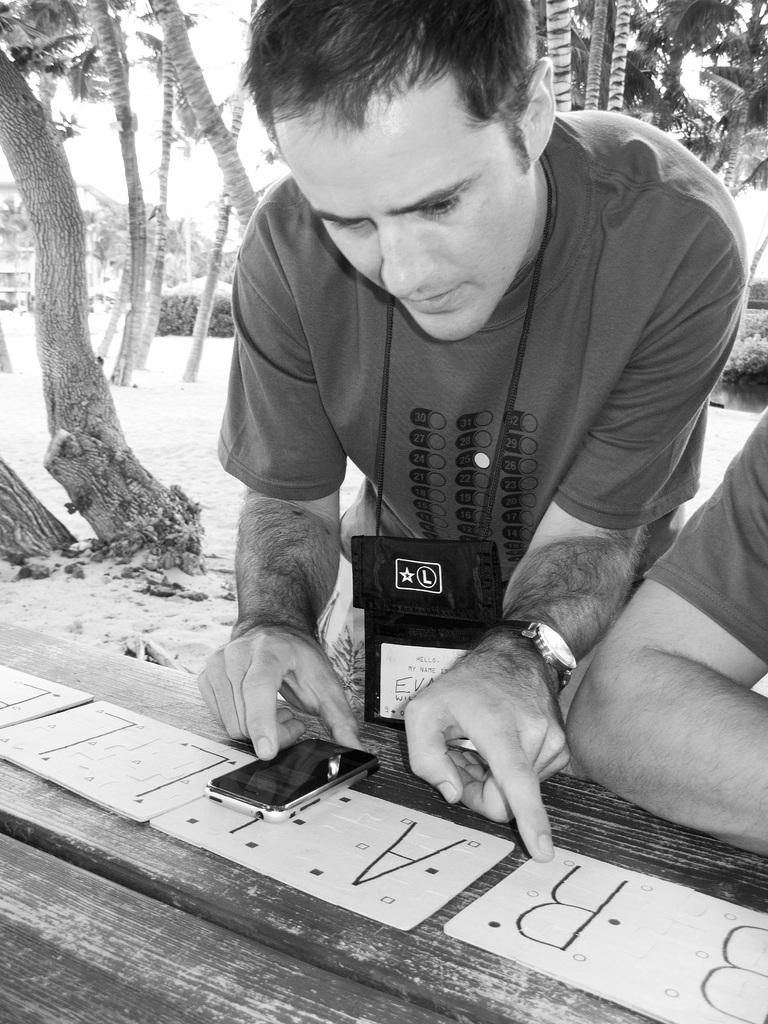How many people are in the image? There are two people in the image. Where are the people located in the image? The people are in the front of the image. What object can be seen on the table in the image? A mobile phone is present on the table. What can be seen in the background of the image? There are trees and the sky visible in the background of the image. What type of pickle is being used to write on the table in the image? There is no pickle present in the image, and no writing is taking place on the table. 